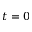<formula> <loc_0><loc_0><loc_500><loc_500>t = 0</formula> 